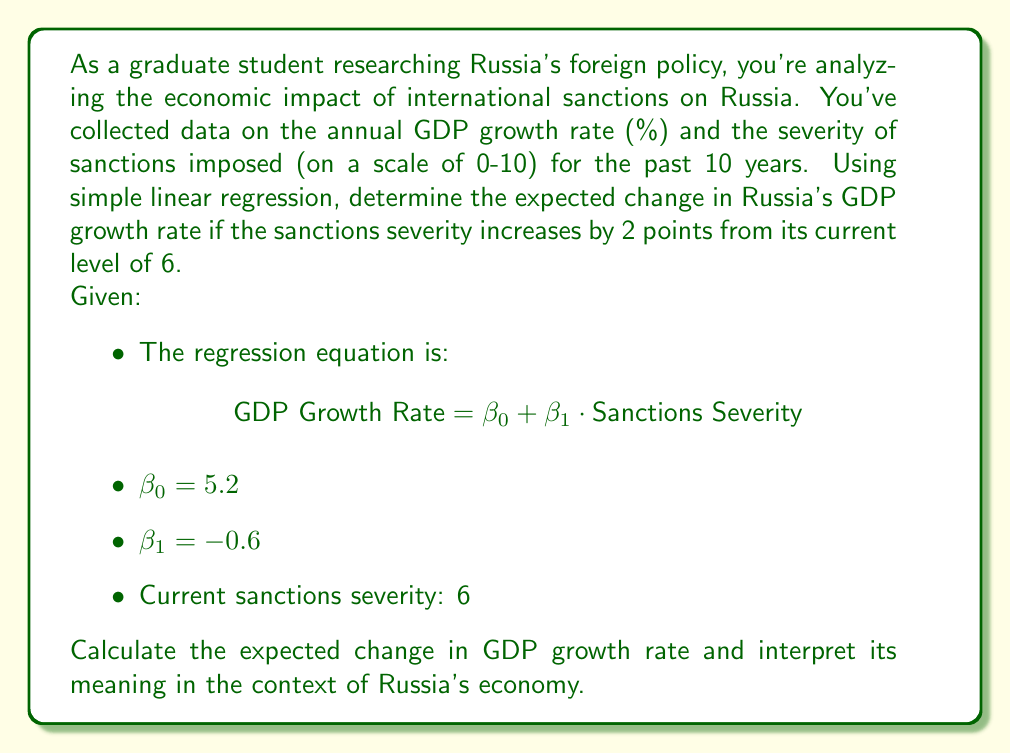Can you solve this math problem? To solve this problem, we'll follow these steps:

1) First, let's recall the simple linear regression equation:
   $$ \text{GDP Growth Rate} = \beta_0 + \beta_1 \cdot \text{Sanctions Severity} $$

2) We're given that $\beta_0 = 5.2$ and $\beta_1 = -0.6$. Let's substitute these values:
   $$ \text{GDP Growth Rate} = 5.2 - 0.6 \cdot \text{Sanctions Severity} $$

3) The current sanctions severity is 6, and we're asked to consider an increase of 2 points. So we need to calculate the GDP growth rate at severity levels 6 and 8.

4) For current severity (6):
   $$ \text{GDP Growth Rate}_{\text{current}} = 5.2 - 0.6 \cdot 6 = 5.2 - 3.6 = 1.6\% $$

5) For increased severity (8):
   $$ \text{GDP Growth Rate}_{\text{increased}} = 5.2 - 0.6 \cdot 8 = 5.2 - 4.8 = 0.4\% $$

6) The change in GDP growth rate is the difference between these two values:
   $$ \Delta \text{GDP Growth Rate} = 0.4\% - 1.6\% = -1.2\% $$

This negative value indicates a decrease in the GDP growth rate.
Answer: The expected change in Russia's GDP growth rate is -1.2 percentage points. This means that if sanctions severity increases by 2 points from its current level, Russia's annual GDP growth rate is expected to decrease by 1.2%. This significant reduction suggests that increased sanctions could have a substantial negative impact on Russia's economic growth, potentially influencing its foreign policy decisions. 